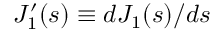<formula> <loc_0><loc_0><loc_500><loc_500>J _ { 1 } ^ { \prime } ( s ) \equiv d J _ { 1 } ( s ) / d s</formula> 